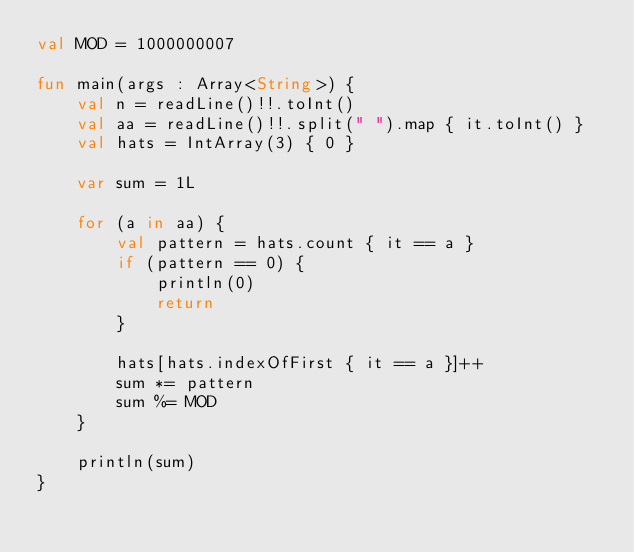<code> <loc_0><loc_0><loc_500><loc_500><_Kotlin_>val MOD = 1000000007

fun main(args : Array<String>) {
    val n = readLine()!!.toInt()
    val aa = readLine()!!.split(" ").map { it.toInt() }
    val hats = IntArray(3) { 0 }

    var sum = 1L

    for (a in aa) {
        val pattern = hats.count { it == a }
        if (pattern == 0) {
            println(0)
            return
        }

        hats[hats.indexOfFirst { it == a }]++
        sum *= pattern
        sum %= MOD
    }

    println(sum)
}</code> 